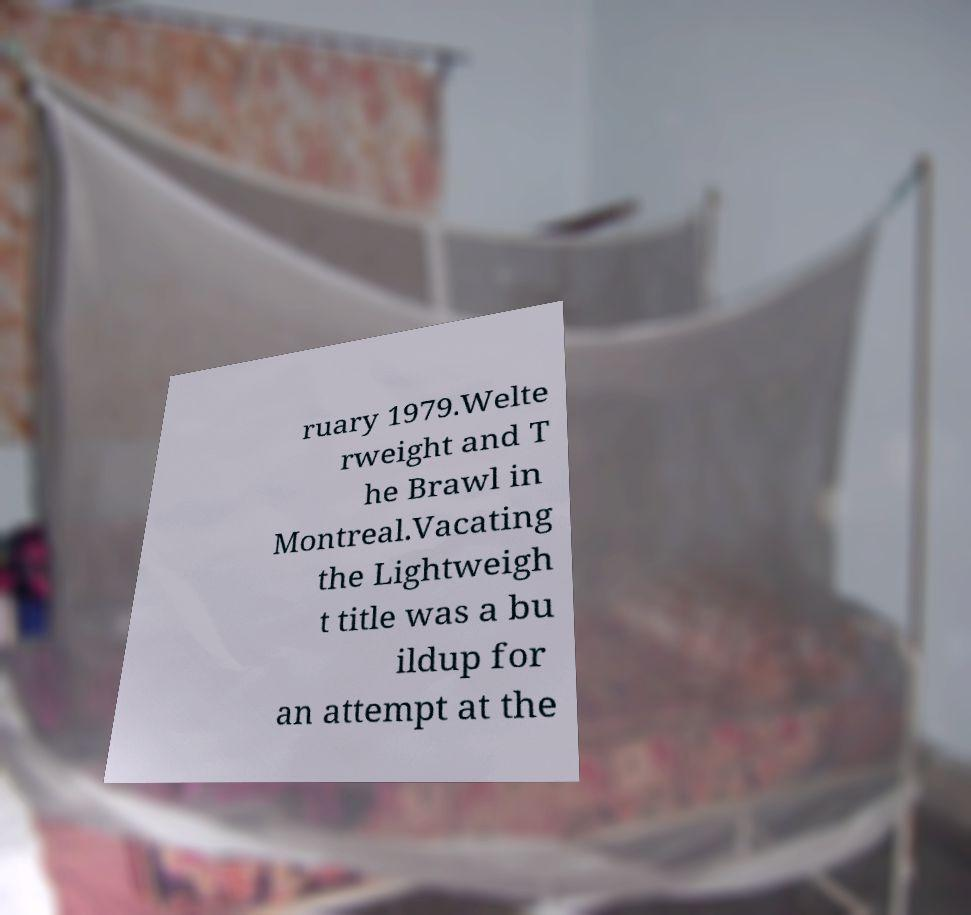I need the written content from this picture converted into text. Can you do that? ruary 1979.Welte rweight and T he Brawl in Montreal.Vacating the Lightweigh t title was a bu ildup for an attempt at the 